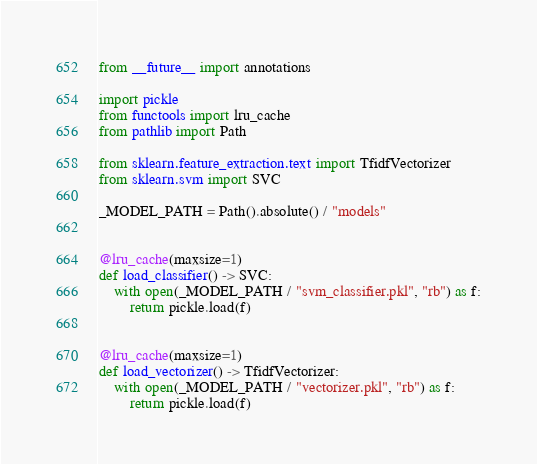Convert code to text. <code><loc_0><loc_0><loc_500><loc_500><_Python_>from __future__ import annotations

import pickle
from functools import lru_cache
from pathlib import Path

from sklearn.feature_extraction.text import TfidfVectorizer
from sklearn.svm import SVC

_MODEL_PATH = Path().absolute() / "models"


@lru_cache(maxsize=1)
def load_classifier() -> SVC:
    with open(_MODEL_PATH / "svm_classifier.pkl", "rb") as f:
        return pickle.load(f)


@lru_cache(maxsize=1)
def load_vectorizer() -> TfidfVectorizer:
    with open(_MODEL_PATH / "vectorizer.pkl", "rb") as f:
        return pickle.load(f)
</code> 